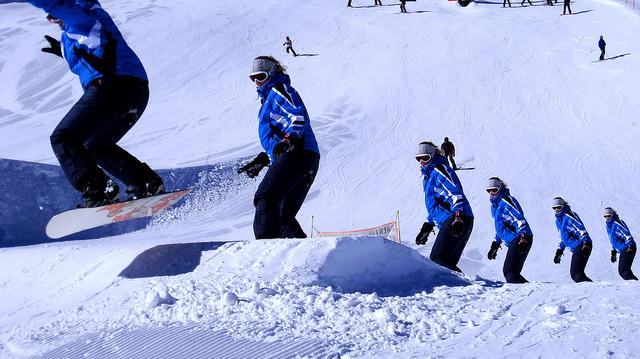What technique was used to manipulate this photo? copying 